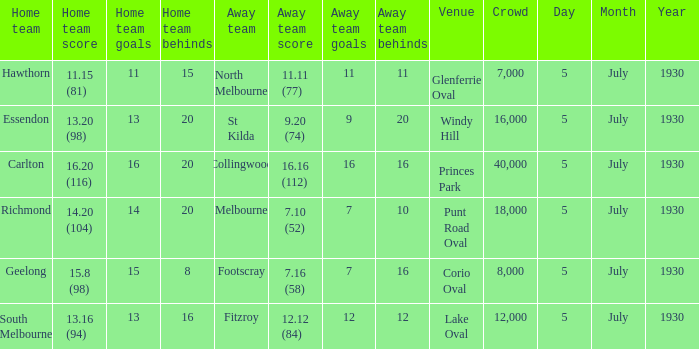On which day is the team scheduled to play at punt road oval? 5 July 1930. 